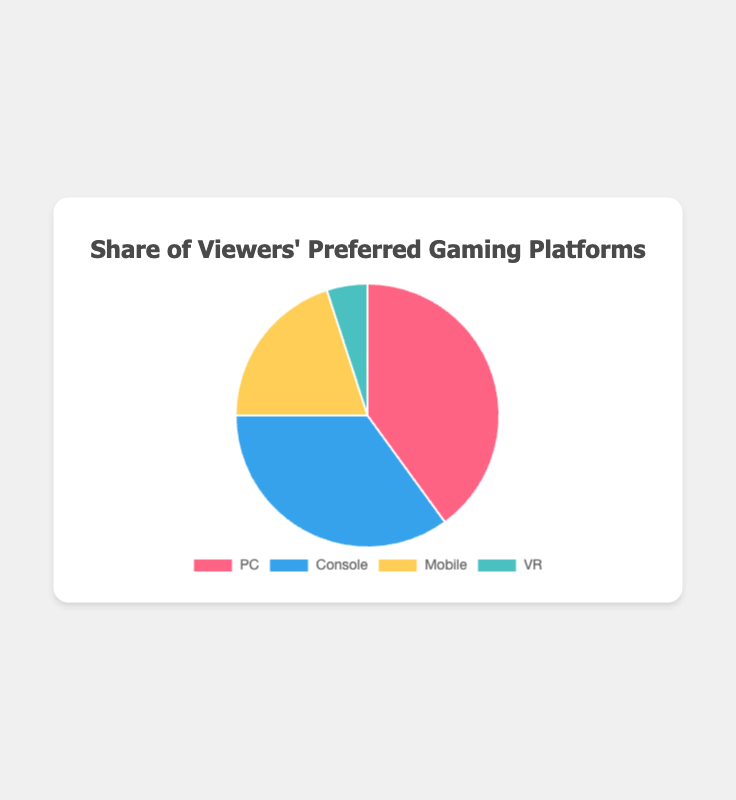What percentage of viewers prefer PC for gaming? The pie chart shows the percentage of viewers' preferred gaming platforms. From the chart, we can see that 40% prefer PC.
Answer: 40% Which platform is the least preferred by viewers? By looking at the pie chart, we can see that VR has the smallest segment, indicating it is the least preferred with 5% of viewers.
Answer: VR How much greater is the preference for Mobile gaming than VR gaming? From the pie chart, we can see Mobile gaming is preferred by 20% and VR by 5%, so the difference is 20% - 5% = 15%.
Answer: 15% What is the combined percentage of viewers who prefer either Console or Mobile gaming? The chart shows Console has 35% and Mobile has 20%. Adding these together gives 35% + 20% = 55%.
Answer: 55% Which platform do viewers prefer more, PC or Console, and by how much? According to the pie chart, PC is preferred by 40% and Console by 35%. The difference is 40% - 35% = 5%.
Answer: PC by 5% What is the percentage difference between the most and least preferred gaming platforms? The pie chart indicates the most preferred platform is PC with 40% and the least preferred is VR with 5%. The difference is 40% - 5% = 35%.
Answer: 35% Which two platforms have a combined preference equal to the preference for PC? The preference for PC is 40%. Looking at the chart, the combined preference of Console (35%) and VR (5%) equals 35% + 5% = 40%.
Answer: Console and VR If a viewer is randomly selected, what is the probability they prefer either PC or Mobile gaming? From the chart, PC has 40% and Mobile has 20%. Adding these gives 40% + 20% = 60%, so the probability is 60%.
Answer: 60% How does the visual representation indicate the preference for each gaming platform? The pie chart uses different colors and segment sizes to represent each platform: red for PC (40%), blue for Console (35%), yellow for Mobile (20%), and turquoise for VR (5%). Larger segments indicate higher preference.
Answer: Different colors and segment sizes montrer the preference 